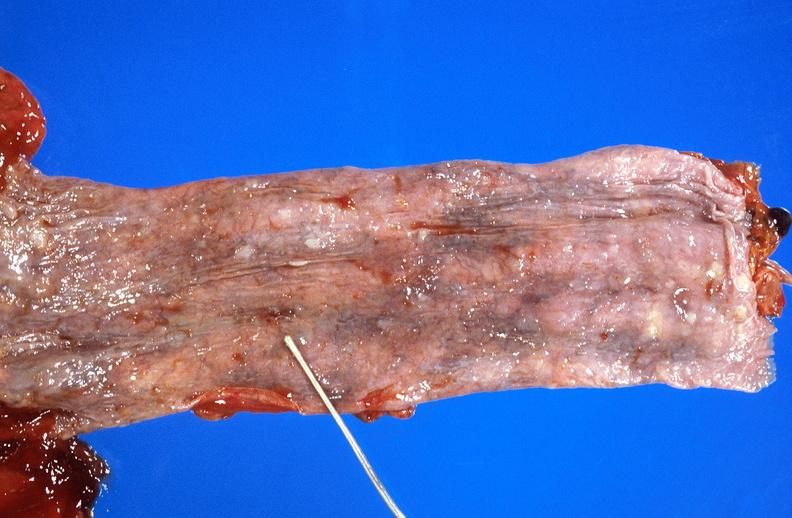why does this image show esophageal varices?
Answer the question using a single word or phrase. Due to alcoholic cirrhosis 